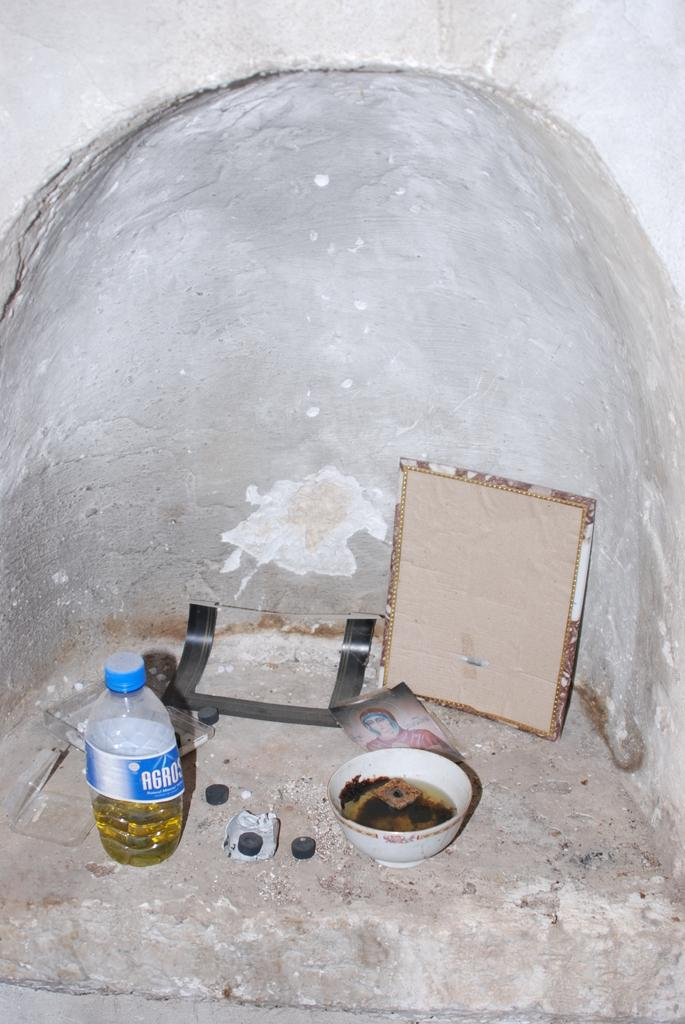What type of structure can be seen in the image? There is a wall in the image. What is located on the wall in the image? There is a frame in the image. What is inside the frame in the image? There is a photo in the image. What other objects can be seen in the image? There is a bowl and a bottle in the image. Where is the lunchroom located in the image? There is no lunchroom present in the image. What type of hammer is being used to hang the photo in the image? There is no hammer visible in the image, and the photo is already hung within the frame. 